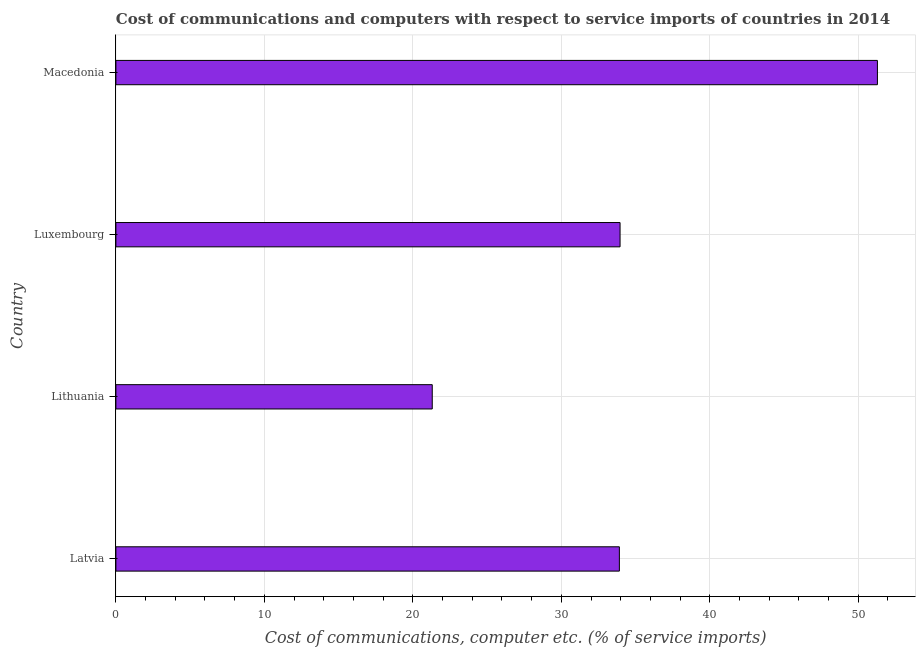Does the graph contain grids?
Your answer should be very brief. Yes. What is the title of the graph?
Give a very brief answer. Cost of communications and computers with respect to service imports of countries in 2014. What is the label or title of the X-axis?
Offer a terse response. Cost of communications, computer etc. (% of service imports). What is the cost of communications and computer in Luxembourg?
Offer a very short reply. 33.96. Across all countries, what is the maximum cost of communications and computer?
Give a very brief answer. 51.29. Across all countries, what is the minimum cost of communications and computer?
Make the answer very short. 21.31. In which country was the cost of communications and computer maximum?
Your answer should be compact. Macedonia. In which country was the cost of communications and computer minimum?
Make the answer very short. Lithuania. What is the sum of the cost of communications and computer?
Make the answer very short. 140.47. What is the difference between the cost of communications and computer in Lithuania and Macedonia?
Your response must be concise. -29.98. What is the average cost of communications and computer per country?
Keep it short and to the point. 35.12. What is the median cost of communications and computer?
Keep it short and to the point. 33.93. In how many countries, is the cost of communications and computer greater than 20 %?
Offer a terse response. 4. What is the ratio of the cost of communications and computer in Latvia to that in Lithuania?
Ensure brevity in your answer.  1.59. Is the cost of communications and computer in Luxembourg less than that in Macedonia?
Offer a very short reply. Yes. Is the difference between the cost of communications and computer in Latvia and Macedonia greater than the difference between any two countries?
Keep it short and to the point. No. What is the difference between the highest and the second highest cost of communications and computer?
Ensure brevity in your answer.  17.33. What is the difference between the highest and the lowest cost of communications and computer?
Ensure brevity in your answer.  29.98. How many bars are there?
Provide a succinct answer. 4. Are all the bars in the graph horizontal?
Your response must be concise. Yes. Are the values on the major ticks of X-axis written in scientific E-notation?
Ensure brevity in your answer.  No. What is the Cost of communications, computer etc. (% of service imports) of Latvia?
Ensure brevity in your answer.  33.91. What is the Cost of communications, computer etc. (% of service imports) of Lithuania?
Offer a terse response. 21.31. What is the Cost of communications, computer etc. (% of service imports) in Luxembourg?
Provide a succinct answer. 33.96. What is the Cost of communications, computer etc. (% of service imports) of Macedonia?
Offer a terse response. 51.29. What is the difference between the Cost of communications, computer etc. (% of service imports) in Latvia and Lithuania?
Offer a terse response. 12.6. What is the difference between the Cost of communications, computer etc. (% of service imports) in Latvia and Luxembourg?
Provide a succinct answer. -0.05. What is the difference between the Cost of communications, computer etc. (% of service imports) in Latvia and Macedonia?
Give a very brief answer. -17.38. What is the difference between the Cost of communications, computer etc. (% of service imports) in Lithuania and Luxembourg?
Keep it short and to the point. -12.65. What is the difference between the Cost of communications, computer etc. (% of service imports) in Lithuania and Macedonia?
Your answer should be compact. -29.98. What is the difference between the Cost of communications, computer etc. (% of service imports) in Luxembourg and Macedonia?
Give a very brief answer. -17.33. What is the ratio of the Cost of communications, computer etc. (% of service imports) in Latvia to that in Lithuania?
Give a very brief answer. 1.59. What is the ratio of the Cost of communications, computer etc. (% of service imports) in Latvia to that in Macedonia?
Offer a very short reply. 0.66. What is the ratio of the Cost of communications, computer etc. (% of service imports) in Lithuania to that in Luxembourg?
Ensure brevity in your answer.  0.63. What is the ratio of the Cost of communications, computer etc. (% of service imports) in Lithuania to that in Macedonia?
Your answer should be compact. 0.41. What is the ratio of the Cost of communications, computer etc. (% of service imports) in Luxembourg to that in Macedonia?
Provide a succinct answer. 0.66. 